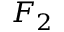<formula> <loc_0><loc_0><loc_500><loc_500>F _ { 2 }</formula> 